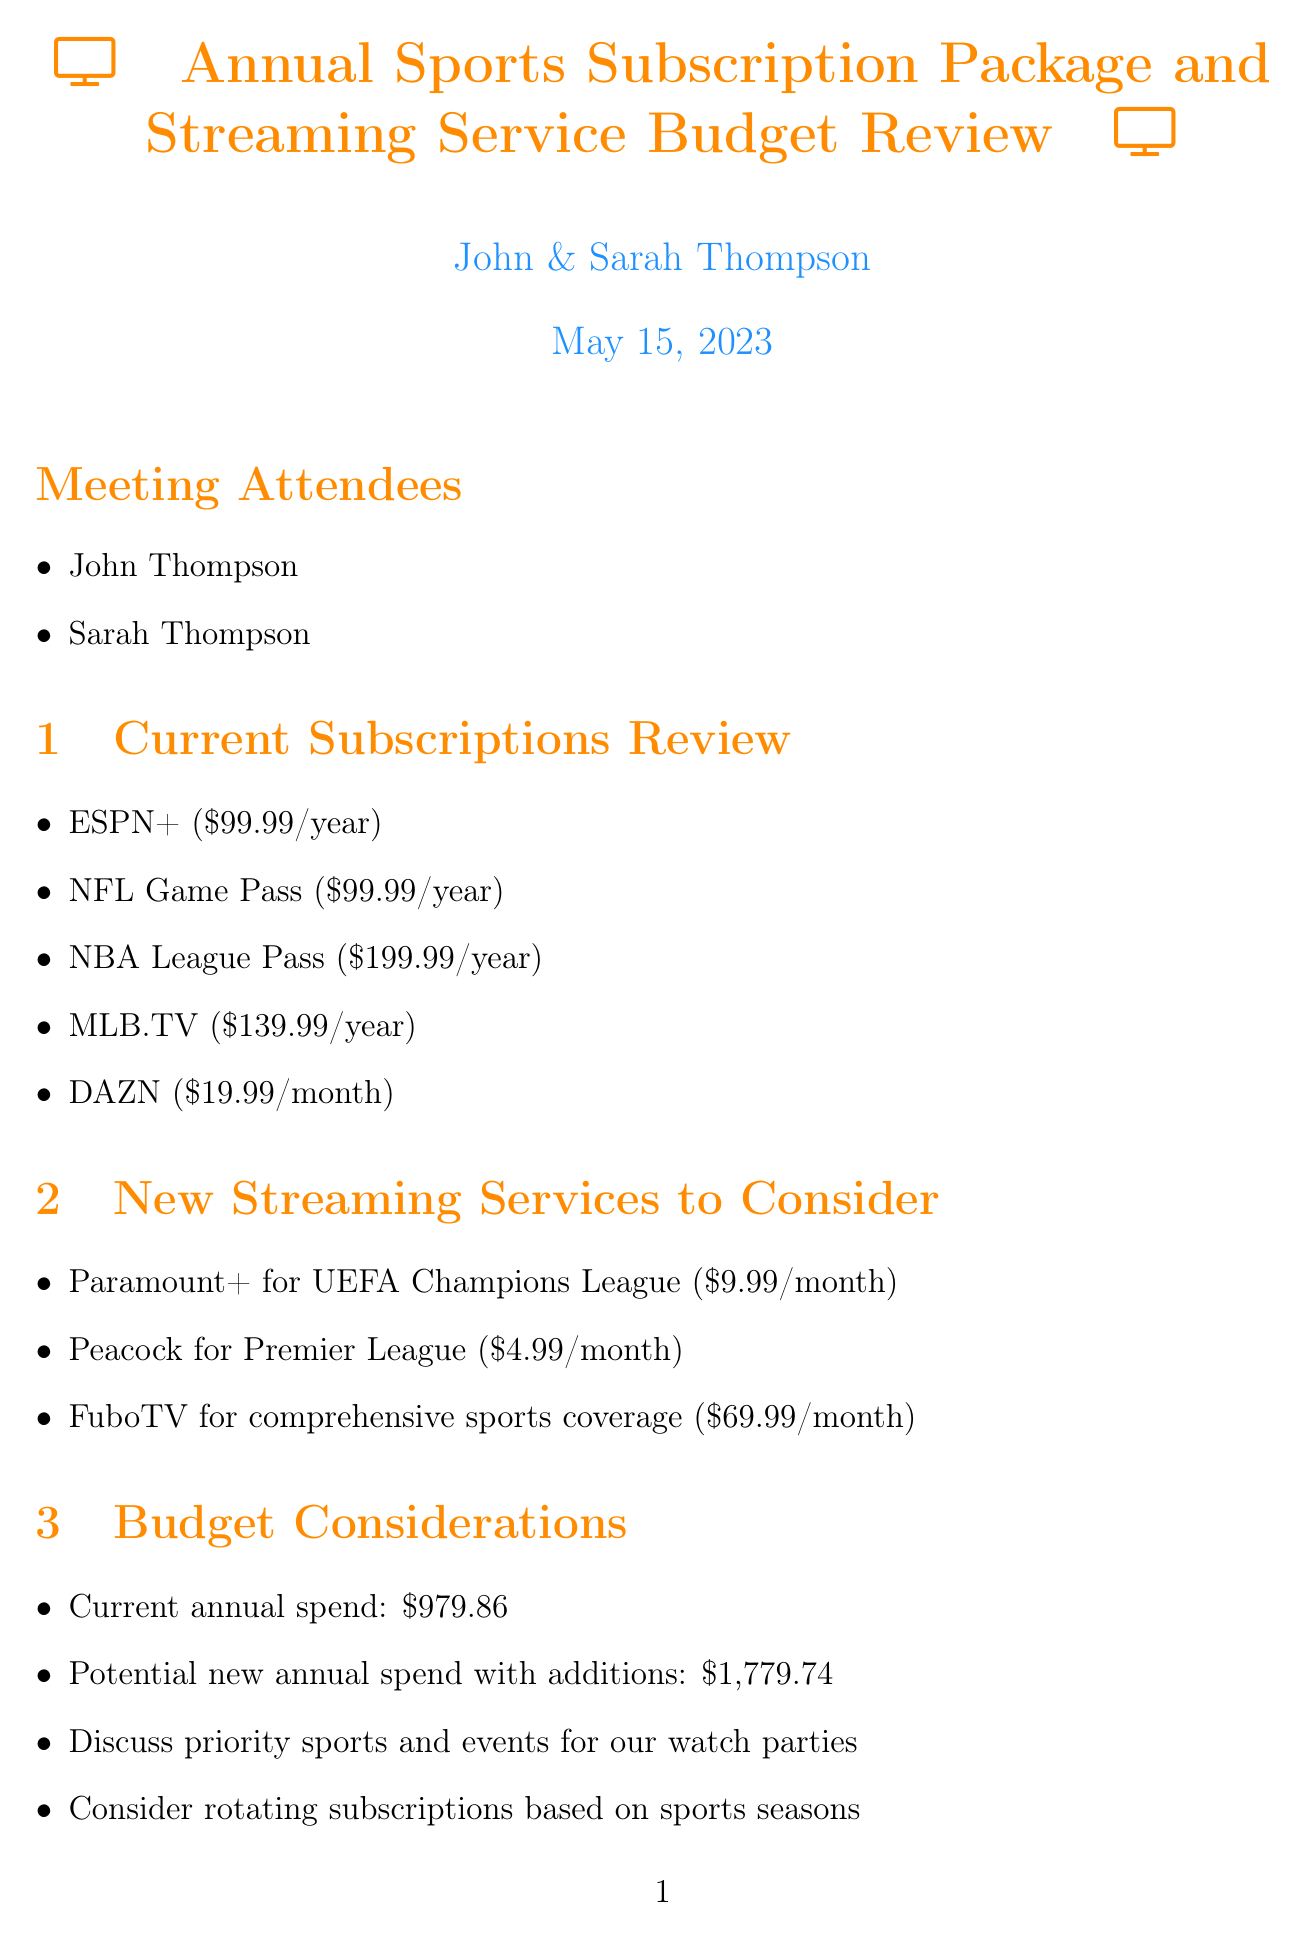What is the current annual spend? The current annual spend is listed in the document as $979.86.
Answer: $979.86 How much would the potential new annual spend be with additions? The potential new annual spend is provided as $1,779.74 in the budget considerations.
Answer: $1,779.74 Which streaming service costs $9.99 a month? The document states that Paramount+ for UEFA Champions League is $9.99/month.
Answer: Paramount+ What is the watch party schedule for the NBA Finals? The document includes the NBA Finals scheduled for June.
Answer: June What cost-saving strategy involves looking for bundle deals? The document mentions looking for bundle deals like Disney+/Hulu/ESPN+ bundle as a cost-saving strategy.
Answer: Bundle deals What sporting event occurs every four years? The FIFA World Cup is mentioned as a sporting event that occurs every four years, with the next one in 2026.
Answer: FIFA World Cup Who attended the meeting? The meeting attendees are listed as John Thompson and Sarah Thompson.
Answer: John Thompson and Sarah Thompson What is one action item discussed in the meeting? One action item is to research bundle options for multiple streaming services as noted in the action items section.
Answer: Research bundle options 